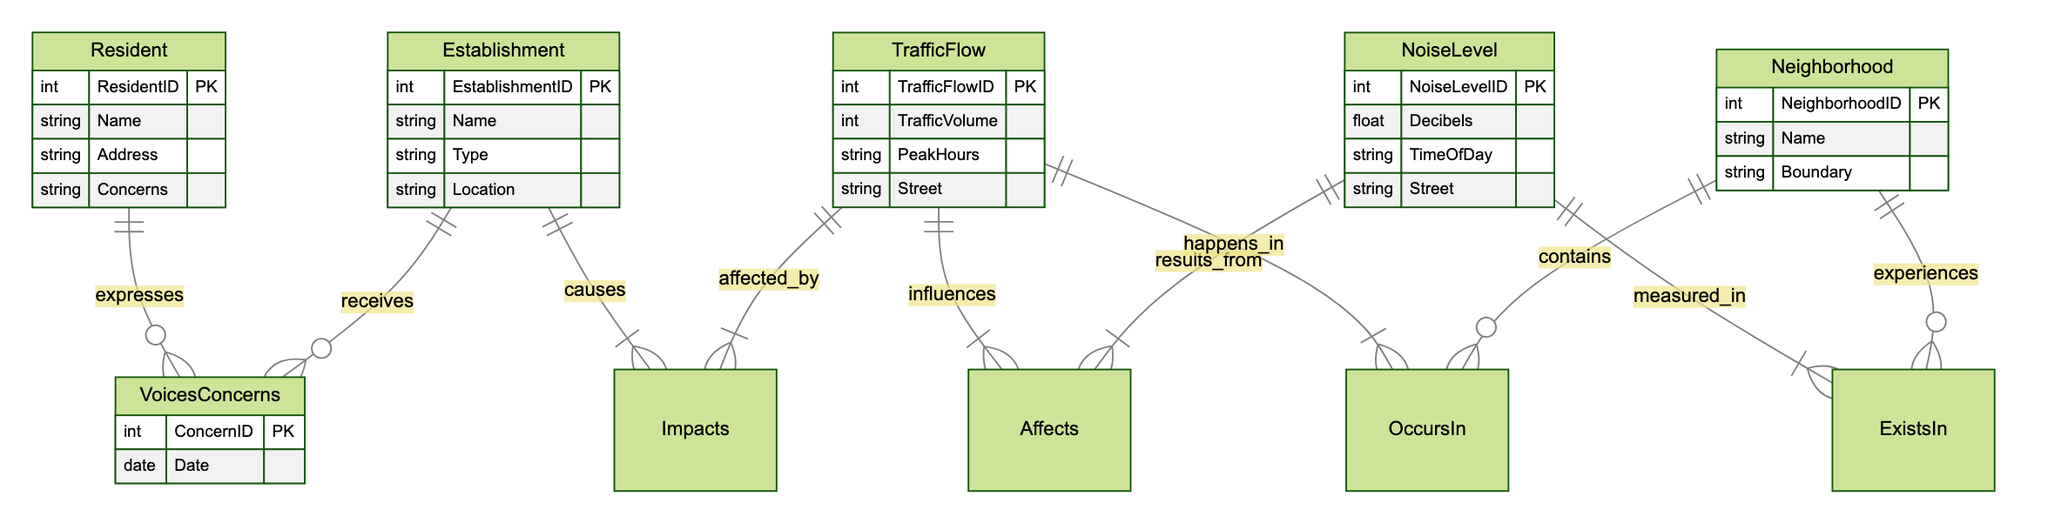What entities are present in the diagram? The diagram includes five entities: Resident, Establishment, TrafficFlow, NoiseLevel, and Neighborhood.
Answer: Resident, Establishment, TrafficFlow, NoiseLevel, Neighborhood How many attributes does the NoiseLevel entity have? The NoiseLevel entity has four attributes: NoiseLevelID, Decibels, TimeOfDay, and Street.
Answer: Four What type of relationship exists between Resident and Establishment? The relationship between Resident and Establishment is named "VoicesConcerns," indicating that residents express their concerns regarding the establishment.
Answer: VoicesConcerns Which entity is impacted by the Establishment according to the diagram? The Establishment impacts the TrafficFlow entity as shown by the "Impacts" relationship.
Answer: TrafficFlow What attribute links the TrafficFlow entity to the Neighborhood? The TrafficFlow entity is linked to the Neighborhood through the relationship "OccursIn."
Answer: OccursIn Which entity measures the NoiseLevel within a neighborhood? The NoiseLevel entity is connected to the Neighborhood through the "ExistsIn" relationship, indicating it is measured within that area.
Answer: Neighborhood Can resident concerns affect noise levels indirectly? Yes, resident concerns about the establishment can relate to how traffic flow changes, which in turn affects noise levels, thus suggesting an indirect influence.
Answer: Yes How many relationships does the TrafficFlow entity participate in? The TrafficFlow entity participates in three relationships: "Impacts," "Affects," and "OccursIn," allowing it to connect to both establishments and neighborhoods.
Answer: Three What is the purpose of the relationship named "Affects"? The relationship "Affects" signifies that changes in TrafficFlow influence NoiseLevel measurements in the neighborhoods.
Answer: Influences NoiseLevel 